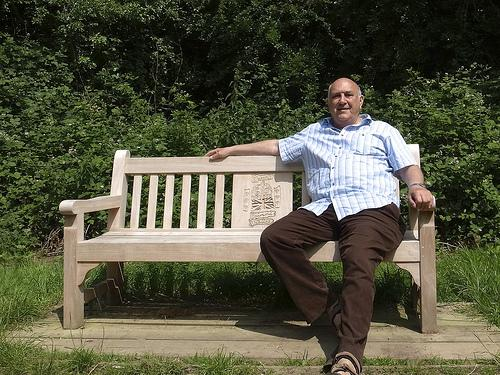Is there any accessory worn by the man in the image? If so, what is it? Yes, the man is wearing a watch on his wrist. List three objects that can be found in the image besides the man. Wooden bench, green leaves in brown trees, and concrete slab beneath the bench. Give a description of the bench the man is sitting on. The bench is light brown, wooden, and has a drawing on the backrest. There is a concrete slab beneath it. Describe the environment around the man in the image. The man is surrounded by thick green trees and tall green grass, with a shadow cast on the ground. What type of footwear is the man wearing in the image, and what color are they? The man is wearing brown sandals in the image. What kind of hair does the man have and where is it located? The man has white hair on his head. In the image, where is the man situated and what is he doing? The man is sitting on a wooden bench outdoors, possibly in a park or garden area. What type of outdoor setting is evident in the image? There are tall green trees and long green grass surrounding a wooden bench in the image. What kind of pants is the man wearing and what color are they? The man is wearing brown dress pants. Mention the color and pattern of the shirt that the man is wearing. The man is wearing a blue and white striped shirt. Can you identify the purple butterfly flying near the man's head? There is no mention of a butterfly in the given image information, let alone a purple one. It is misleading because it directs the user to search for something that does not exist in the image. Notice the red car parked behind the bench, and tell me what model it is. There is no mention of a car, particularly a red one, in the given image information. The instruction is misleading because it asks the user to identify a detail that is not available from the image. Spot the umbrella hanging on the tree with green leaves and tell me its color. While there are mentions of trees with green leaves, there is no mention of an umbrella in the given image information. This instruction is misleading because it leads the user to search for an object that is not within the image. Do you see the group of children playing near the tall green grass? What are they wearing? There is no mention of children or any group of people, apart from the man sitting on the bench, in the given image information. This instruction is misleading because it directs the user to look for a group of subjects that do not appear in the image. Find the woman walking her dog in the background and describe her outfit. There is no mention of a woman or a dog in the given image information. This instruction is misleading because it asks the user to find and describe something that is not present in the image. Find the white bird perched on the bench and describe its features. There is no mention of a bird in the given image information. This instruction misleads the user because it suggests that there is an additional subject within the image that needs to be described, when in reality, it does not exist. 